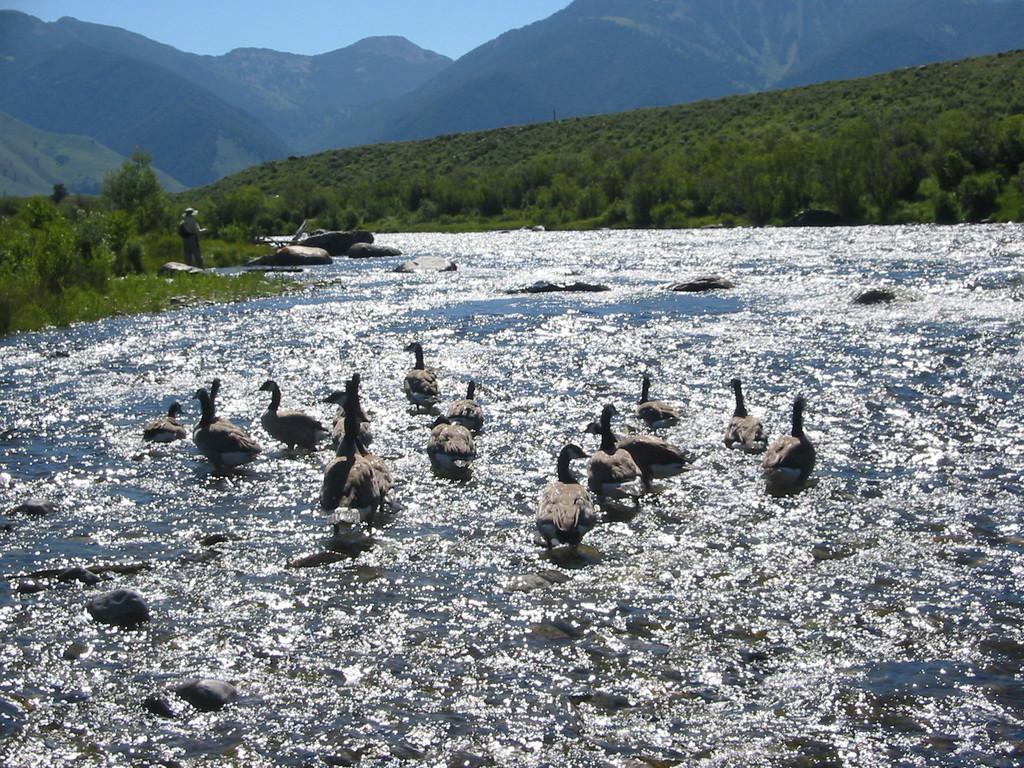Describe this image in one or two sentences. In this image, there are rocks and ducks in the water. I can see a person standing and there are trees, plants and mountains. In the background, there is the sky. 